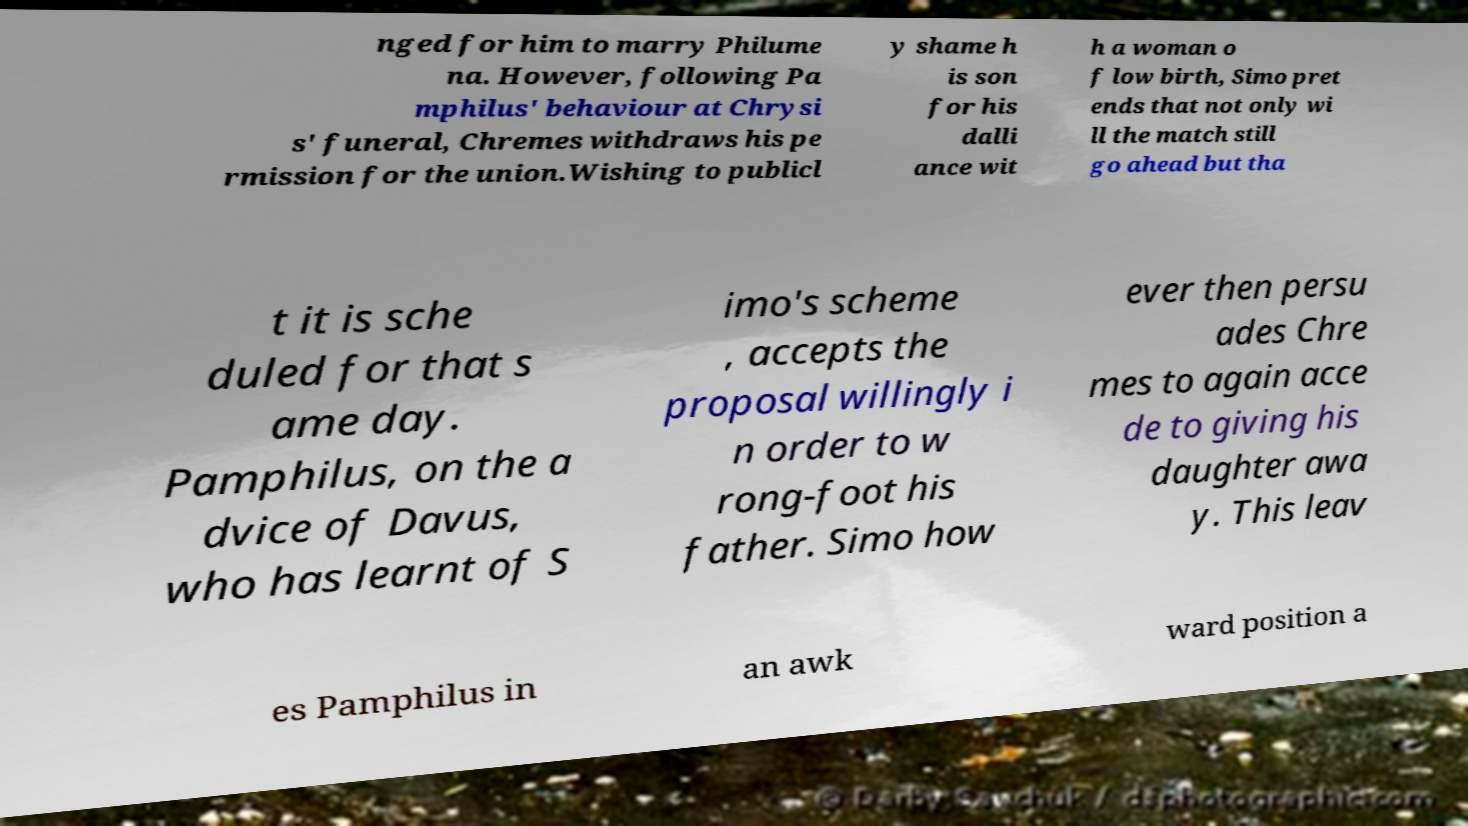Can you accurately transcribe the text from the provided image for me? nged for him to marry Philume na. However, following Pa mphilus' behaviour at Chrysi s' funeral, Chremes withdraws his pe rmission for the union.Wishing to publicl y shame h is son for his dalli ance wit h a woman o f low birth, Simo pret ends that not only wi ll the match still go ahead but tha t it is sche duled for that s ame day. Pamphilus, on the a dvice of Davus, who has learnt of S imo's scheme , accepts the proposal willingly i n order to w rong-foot his father. Simo how ever then persu ades Chre mes to again acce de to giving his daughter awa y. This leav es Pamphilus in an awk ward position a 